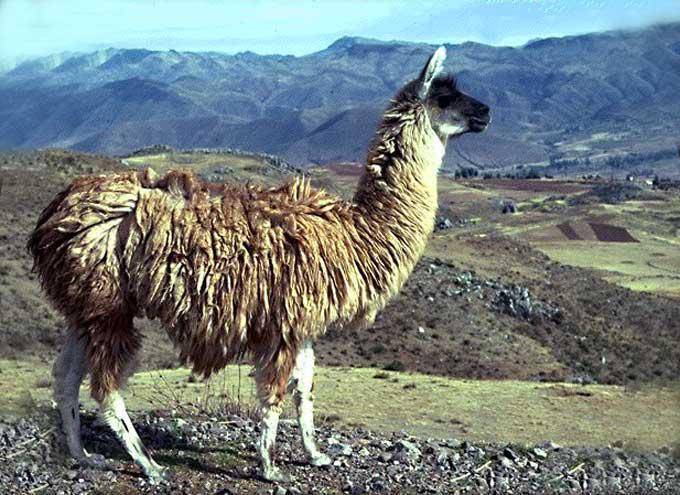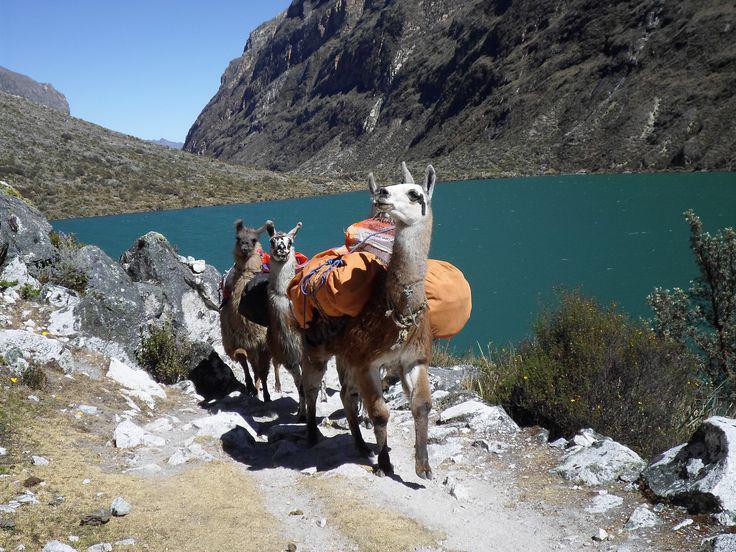The first image is the image on the left, the second image is the image on the right. For the images displayed, is the sentence "In one image, a single llama without a pack is standing on a cliff edge overlooking scenery with mountains in the background." factually correct? Answer yes or no. Yes. The first image is the image on the left, the second image is the image on the right. For the images shown, is this caption "At least three animals are on the mountain together in each picture." true? Answer yes or no. No. 